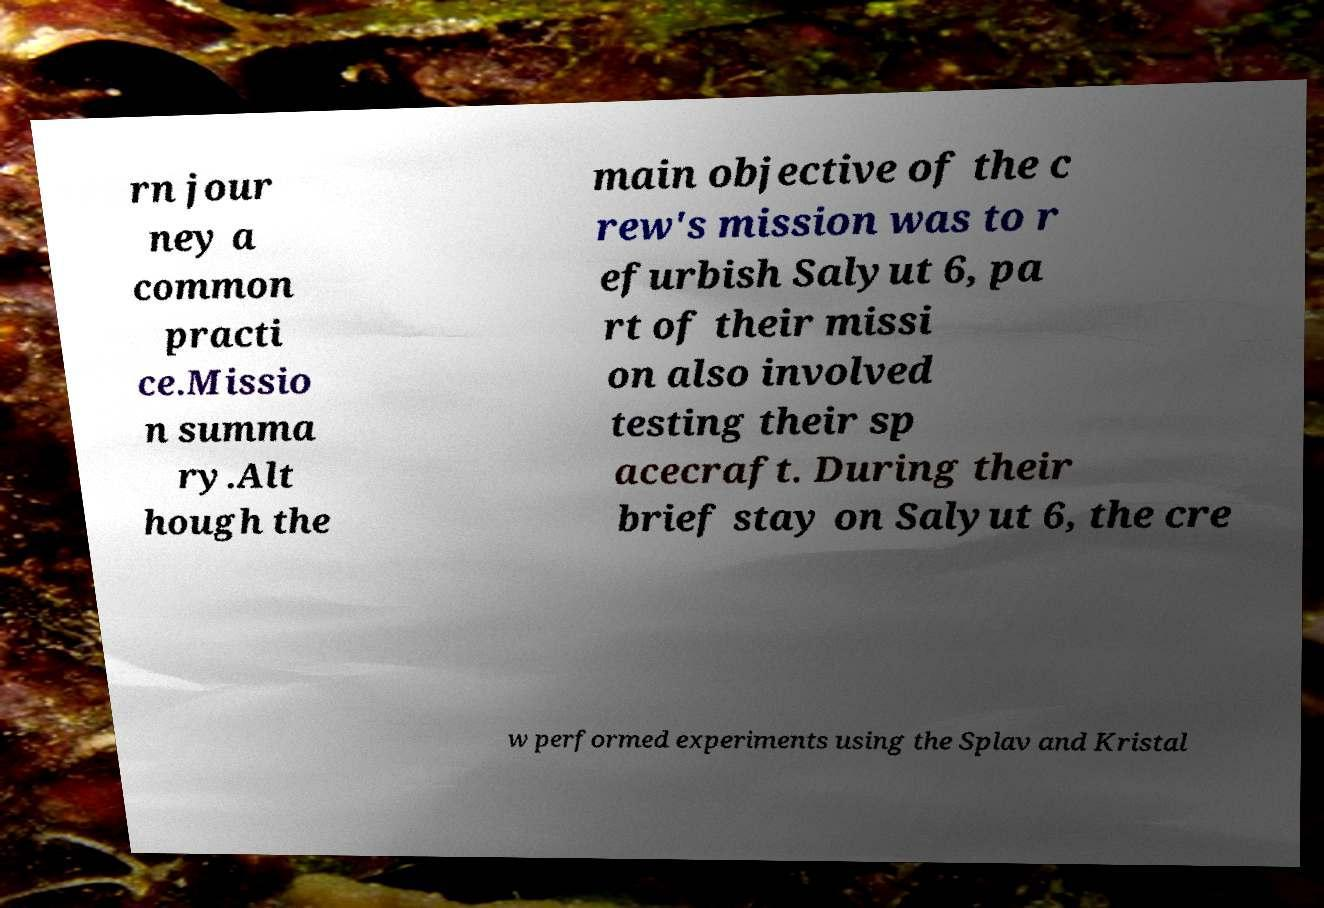What messages or text are displayed in this image? I need them in a readable, typed format. rn jour ney a common practi ce.Missio n summa ry.Alt hough the main objective of the c rew's mission was to r efurbish Salyut 6, pa rt of their missi on also involved testing their sp acecraft. During their brief stay on Salyut 6, the cre w performed experiments using the Splav and Kristal 